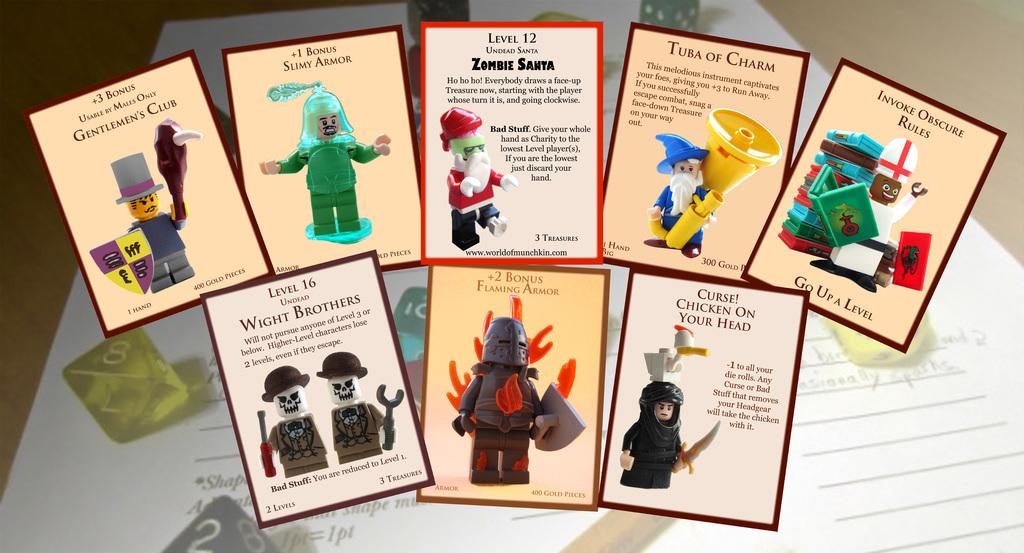<image>
Give a short and clear explanation of the subsequent image. Bunch of cards and one of them has the label of Tuba of Charm. 